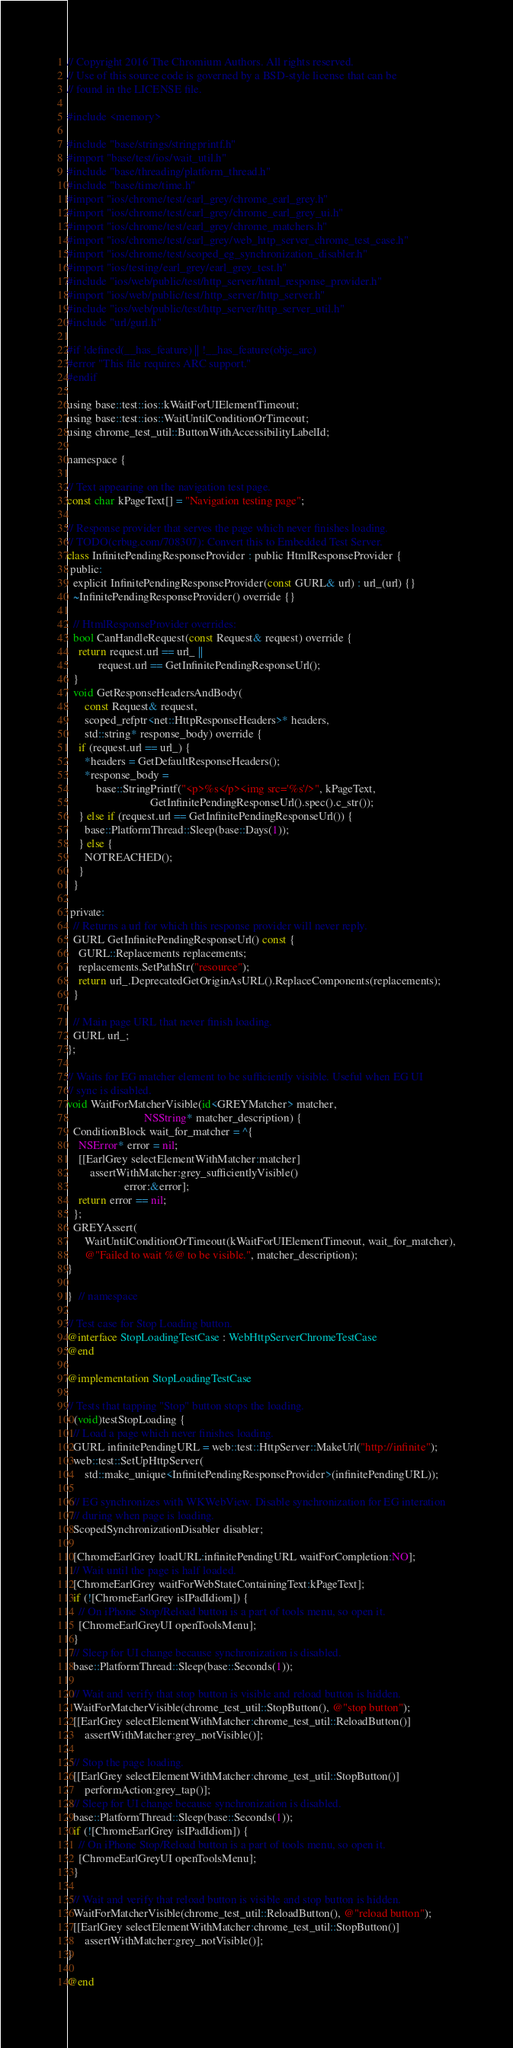Convert code to text. <code><loc_0><loc_0><loc_500><loc_500><_ObjectiveC_>// Copyright 2016 The Chromium Authors. All rights reserved.
// Use of this source code is governed by a BSD-style license that can be
// found in the LICENSE file.

#include <memory>

#include "base/strings/stringprintf.h"
#import "base/test/ios/wait_util.h"
#include "base/threading/platform_thread.h"
#include "base/time/time.h"
#import "ios/chrome/test/earl_grey/chrome_earl_grey.h"
#import "ios/chrome/test/earl_grey/chrome_earl_grey_ui.h"
#import "ios/chrome/test/earl_grey/chrome_matchers.h"
#import "ios/chrome/test/earl_grey/web_http_server_chrome_test_case.h"
#import "ios/chrome/test/scoped_eg_synchronization_disabler.h"
#import "ios/testing/earl_grey/earl_grey_test.h"
#include "ios/web/public/test/http_server/html_response_provider.h"
#import "ios/web/public/test/http_server/http_server.h"
#include "ios/web/public/test/http_server/http_server_util.h"
#include "url/gurl.h"

#if !defined(__has_feature) || !__has_feature(objc_arc)
#error "This file requires ARC support."
#endif

using base::test::ios::kWaitForUIElementTimeout;
using base::test::ios::WaitUntilConditionOrTimeout;
using chrome_test_util::ButtonWithAccessibilityLabelId;

namespace {

// Text appearing on the navigation test page.
const char kPageText[] = "Navigation testing page";

// Response provider that serves the page which never finishes loading.
// TODO(crbug.com/708307): Convert this to Embedded Test Server.
class InfinitePendingResponseProvider : public HtmlResponseProvider {
 public:
  explicit InfinitePendingResponseProvider(const GURL& url) : url_(url) {}
  ~InfinitePendingResponseProvider() override {}

  // HtmlResponseProvider overrides:
  bool CanHandleRequest(const Request& request) override {
    return request.url == url_ ||
           request.url == GetInfinitePendingResponseUrl();
  }
  void GetResponseHeadersAndBody(
      const Request& request,
      scoped_refptr<net::HttpResponseHeaders>* headers,
      std::string* response_body) override {
    if (request.url == url_) {
      *headers = GetDefaultResponseHeaders();
      *response_body =
          base::StringPrintf("<p>%s</p><img src='%s'/>", kPageText,
                             GetInfinitePendingResponseUrl().spec().c_str());
    } else if (request.url == GetInfinitePendingResponseUrl()) {
      base::PlatformThread::Sleep(base::Days(1));
    } else {
      NOTREACHED();
    }
  }

 private:
  // Returns a url for which this response provider will never reply.
  GURL GetInfinitePendingResponseUrl() const {
    GURL::Replacements replacements;
    replacements.SetPathStr("resource");
    return url_.DeprecatedGetOriginAsURL().ReplaceComponents(replacements);
  }

  // Main page URL that never finish loading.
  GURL url_;
};

// Waits for EG matcher element to be sufficiently visible. Useful when EG UI
// sync is disabled.
void WaitForMatcherVisible(id<GREYMatcher> matcher,
                           NSString* matcher_description) {
  ConditionBlock wait_for_matcher = ^{
    NSError* error = nil;
    [[EarlGrey selectElementWithMatcher:matcher]
        assertWithMatcher:grey_sufficientlyVisible()
                    error:&error];
    return error == nil;
  };
  GREYAssert(
      WaitUntilConditionOrTimeout(kWaitForUIElementTimeout, wait_for_matcher),
      @"Failed to wait %@ to be visible.", matcher_description);
}

}  // namespace

// Test case for Stop Loading button.
@interface StopLoadingTestCase : WebHttpServerChromeTestCase
@end

@implementation StopLoadingTestCase

// Tests that tapping "Stop" button stops the loading.
- (void)testStopLoading {
  // Load a page which never finishes loading.
  GURL infinitePendingURL = web::test::HttpServer::MakeUrl("http://infinite");
  web::test::SetUpHttpServer(
      std::make_unique<InfinitePendingResponseProvider>(infinitePendingURL));

  // EG synchronizes with WKWebView. Disable synchronization for EG interation
  // during when page is loading.
  ScopedSynchronizationDisabler disabler;

  [ChromeEarlGrey loadURL:infinitePendingURL waitForCompletion:NO];
  // Wait until the page is half loaded.
  [ChromeEarlGrey waitForWebStateContainingText:kPageText];
  if (![ChromeEarlGrey isIPadIdiom]) {
    // On iPhone Stop/Reload button is a part of tools menu, so open it.
    [ChromeEarlGreyUI openToolsMenu];
  }
  // Sleep for UI change because synchronization is disabled.
  base::PlatformThread::Sleep(base::Seconds(1));

  // Wait and verify that stop button is visible and reload button is hidden.
  WaitForMatcherVisible(chrome_test_util::StopButton(), @"stop button");
  [[EarlGrey selectElementWithMatcher:chrome_test_util::ReloadButton()]
      assertWithMatcher:grey_notVisible()];

  // Stop the page loading.
  [[EarlGrey selectElementWithMatcher:chrome_test_util::StopButton()]
      performAction:grey_tap()];
  // Sleep for UI change because synchronization is disabled.
  base::PlatformThread::Sleep(base::Seconds(1));
  if (![ChromeEarlGrey isIPadIdiom]) {
    // On iPhone Stop/Reload button is a part of tools menu, so open it.
    [ChromeEarlGreyUI openToolsMenu];
  }

  // Wait and verify that reload button is visible and stop button is hidden.
  WaitForMatcherVisible(chrome_test_util::ReloadButton(), @"reload button");
  [[EarlGrey selectElementWithMatcher:chrome_test_util::StopButton()]
      assertWithMatcher:grey_notVisible()];
}

@end
</code> 